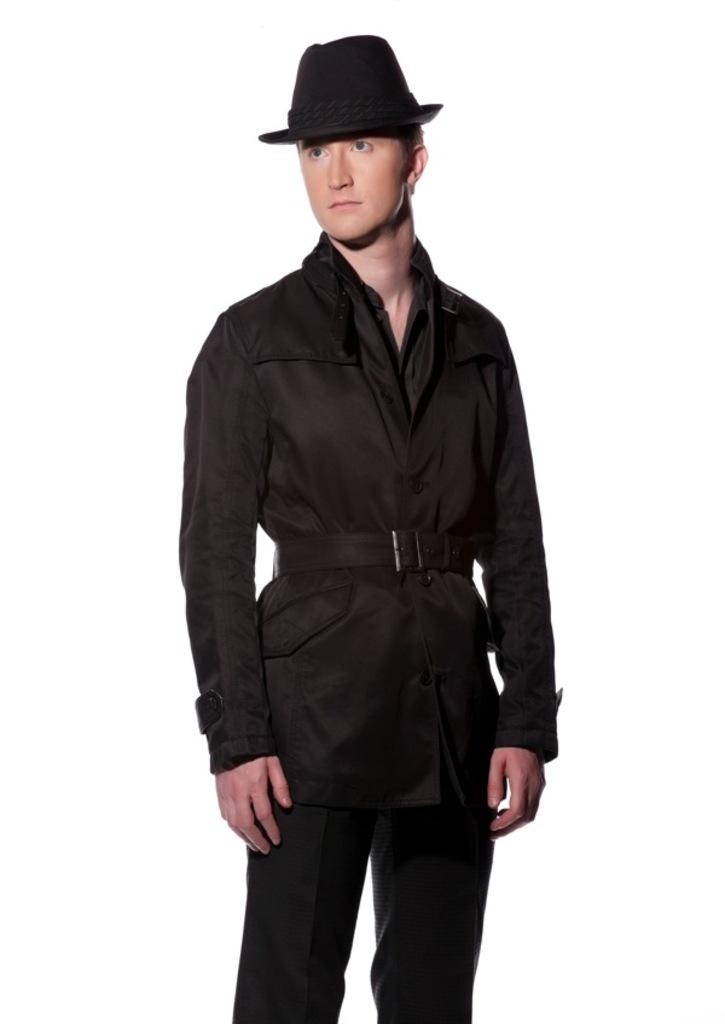Who is the main subject in the picture? There is a person in the center of the picture. What is the person wearing? The person is wearing a black dress and a black hat. What is the color of the background in the image? The background of the image is white. How many kittens are sitting on the person's lap in the image? There are no kittens present in the image. What type of milk is the person holding in the image? There is no milk visible in the image. 